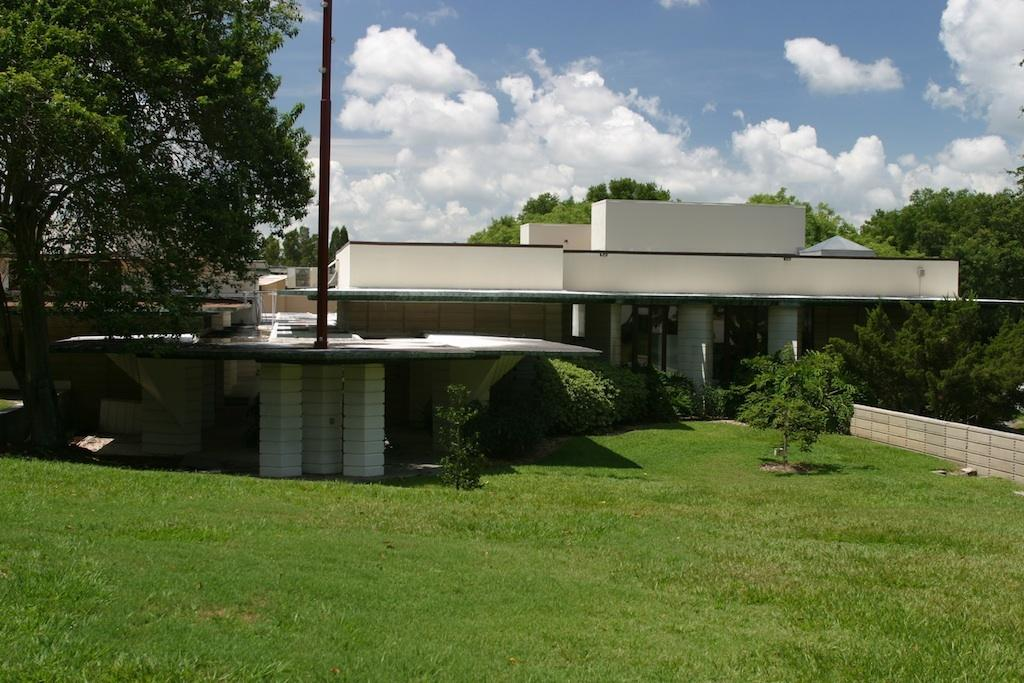What type of structures can be seen in the image? There are houses in the image. What type of vegetation is present in the image? There are plants, trees, and grass in the image. What object can be seen standing upright in the image? There is a pole in the image. What type of barrier is present in the image? There is a wall in the image. What part of the natural environment is visible in the image? The sky is visible in the background of the image, with clouds present. Can you see someone skating on the grass in the image? There is no one skating on the grass in the image. What type of bun is being used to hold up the plants in the image? There are no buns present in the image; the plants are not being held up by any buns. 